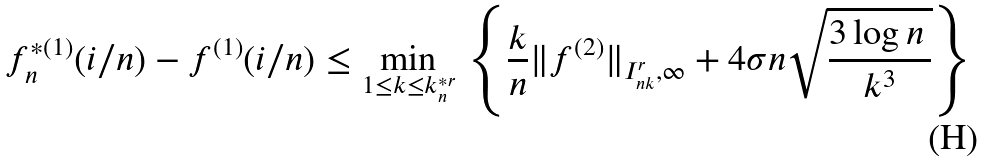Convert formula to latex. <formula><loc_0><loc_0><loc_500><loc_500>f _ { n } ^ { * ( 1 ) } ( i / n ) - f ^ { ( 1 ) } ( i / n ) \leq \min _ { 1 \leq k \leq k ^ { * r } _ { n } } \, \left \{ \frac { k } { n } \| f ^ { ( 2 ) } \| _ { I _ { n k } ^ { r } , \infty } + 4 \sigma n \sqrt { \frac { 3 \log n \, } { k ^ { 3 } } } \right \}</formula> 